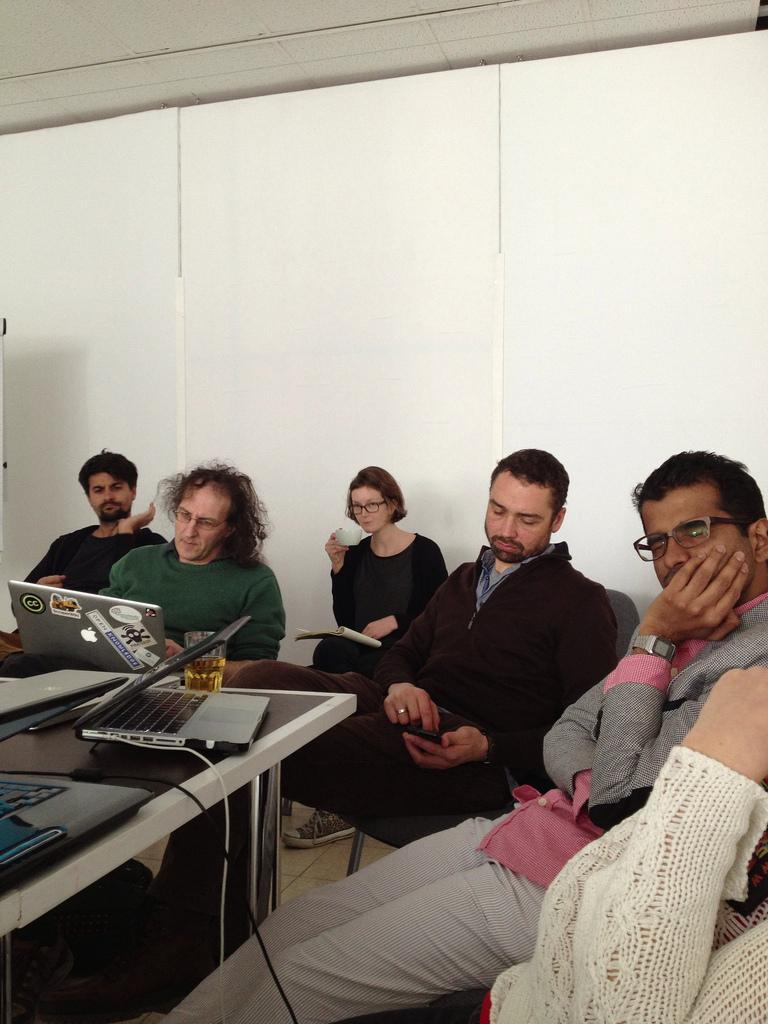Could you give a brief overview of what you see in this image? This image is clicked in a room. There are table and chairs in this room. People are sitting on chairs. Table is in the bottom left corner. On the table there are laptops placed. 